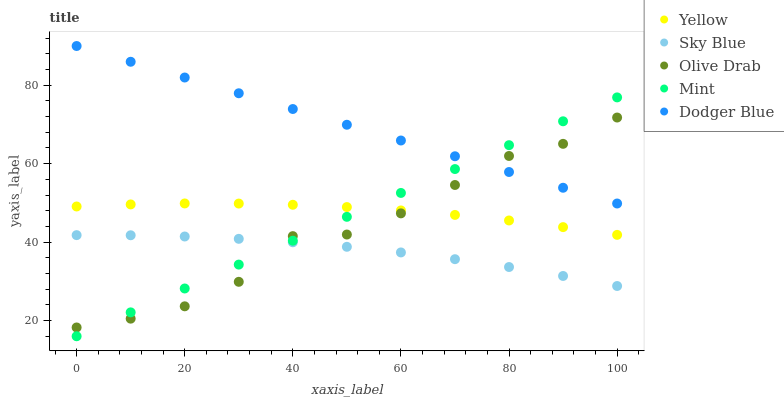Does Sky Blue have the minimum area under the curve?
Answer yes or no. Yes. Does Dodger Blue have the maximum area under the curve?
Answer yes or no. Yes. Does Mint have the minimum area under the curve?
Answer yes or no. No. Does Mint have the maximum area under the curve?
Answer yes or no. No. Is Dodger Blue the smoothest?
Answer yes or no. Yes. Is Olive Drab the roughest?
Answer yes or no. Yes. Is Mint the smoothest?
Answer yes or no. No. Is Mint the roughest?
Answer yes or no. No. Does Mint have the lowest value?
Answer yes or no. Yes. Does Olive Drab have the lowest value?
Answer yes or no. No. Does Dodger Blue have the highest value?
Answer yes or no. Yes. Does Mint have the highest value?
Answer yes or no. No. Is Yellow less than Dodger Blue?
Answer yes or no. Yes. Is Yellow greater than Sky Blue?
Answer yes or no. Yes. Does Olive Drab intersect Yellow?
Answer yes or no. Yes. Is Olive Drab less than Yellow?
Answer yes or no. No. Is Olive Drab greater than Yellow?
Answer yes or no. No. Does Yellow intersect Dodger Blue?
Answer yes or no. No. 